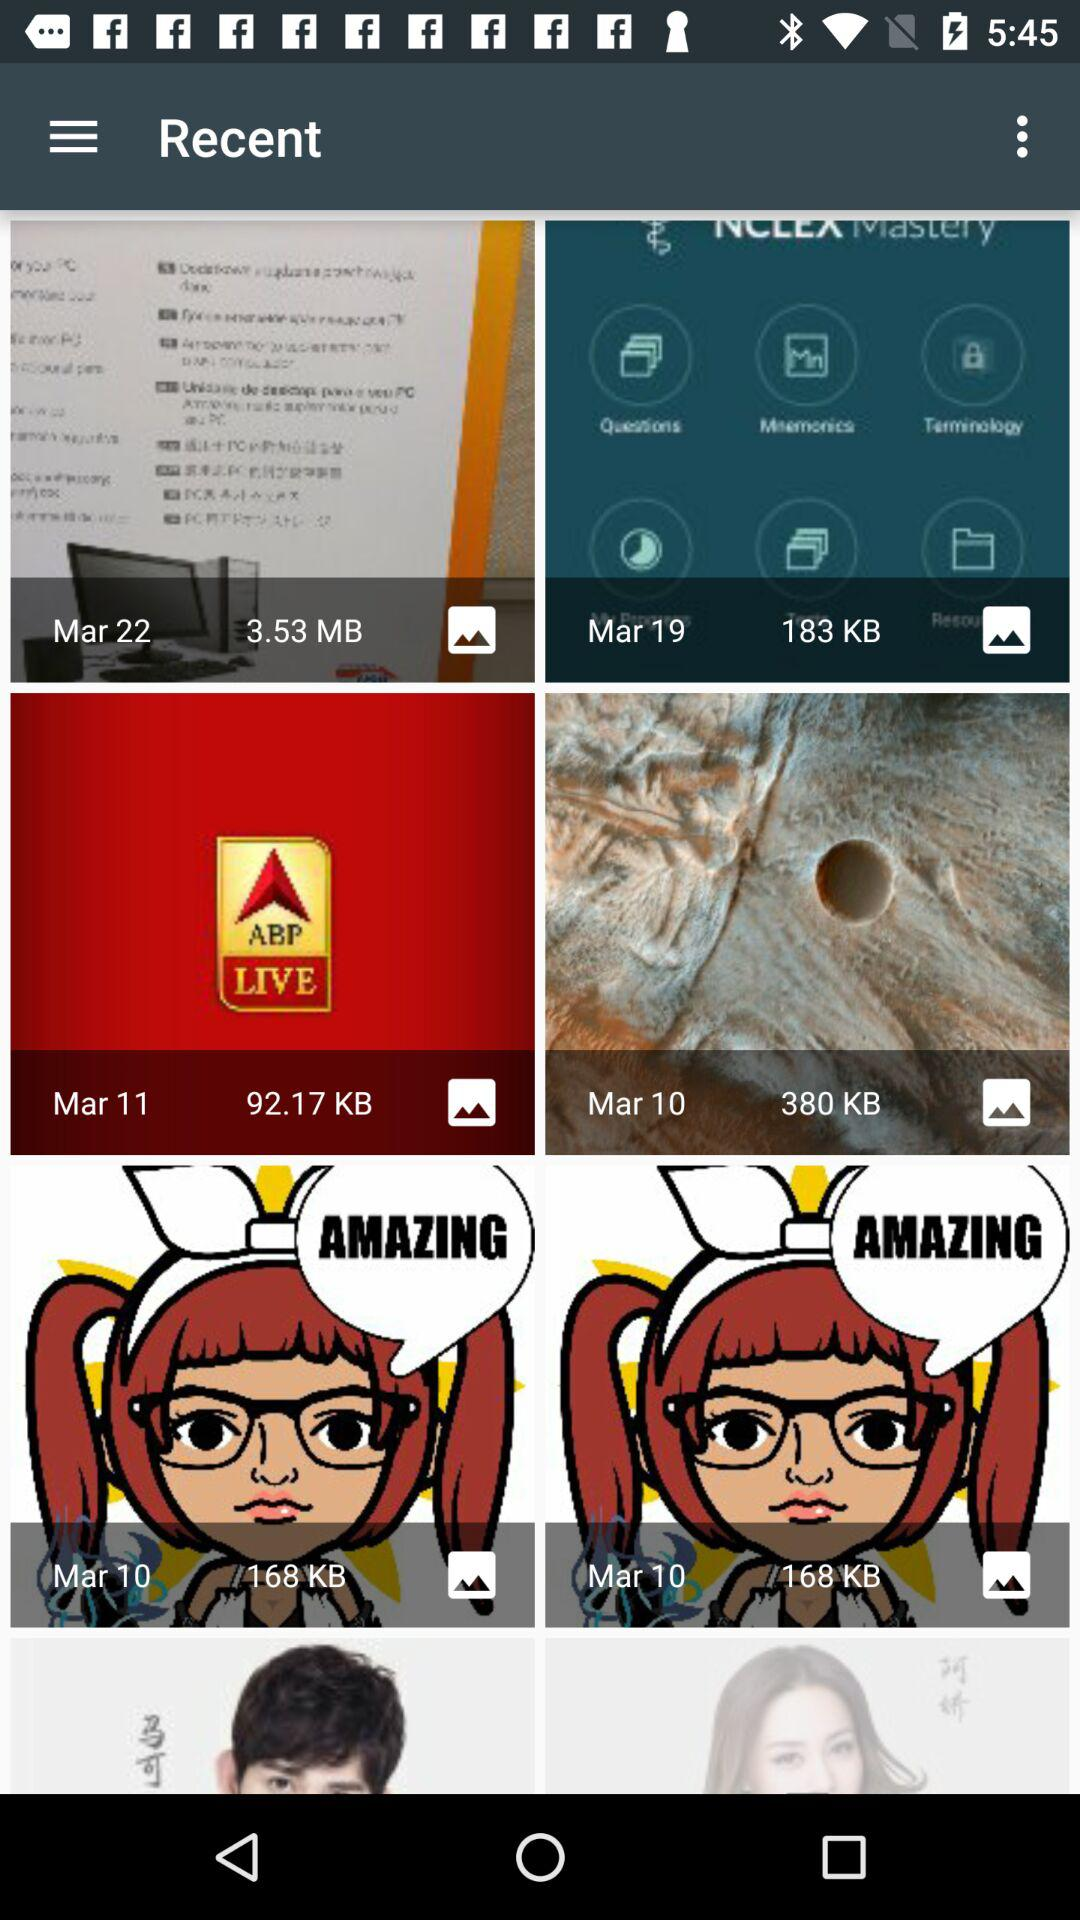What is the size of the image taken on March 11? The size of the image is 92.17 KB. 